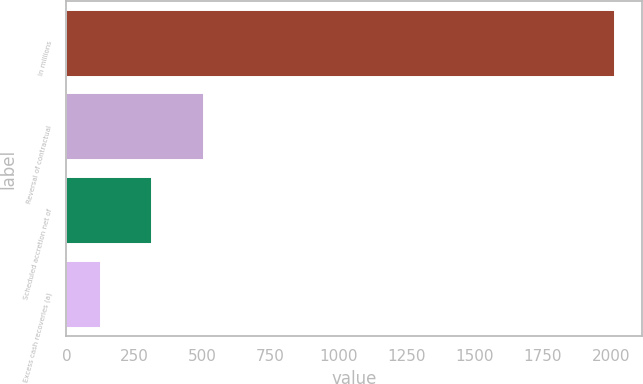Convert chart. <chart><loc_0><loc_0><loc_500><loc_500><bar_chart><fcel>In millions<fcel>Reversal of contractual<fcel>Scheduled accretion net of<fcel>Excess cash recoveries (a)<nl><fcel>2014<fcel>504.4<fcel>315.7<fcel>127<nl></chart> 